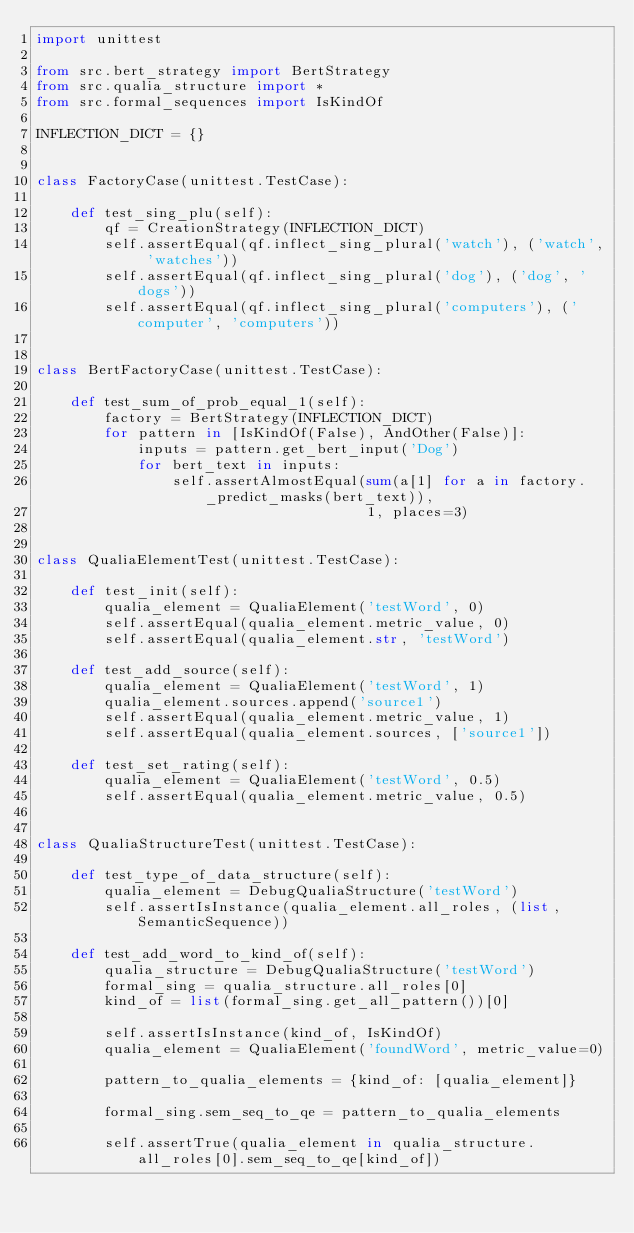Convert code to text. <code><loc_0><loc_0><loc_500><loc_500><_Python_>import unittest

from src.bert_strategy import BertStrategy
from src.qualia_structure import *
from src.formal_sequences import IsKindOf

INFLECTION_DICT = {}


class FactoryCase(unittest.TestCase):

    def test_sing_plu(self):
        qf = CreationStrategy(INFLECTION_DICT)
        self.assertEqual(qf.inflect_sing_plural('watch'), ('watch', 'watches'))
        self.assertEqual(qf.inflect_sing_plural('dog'), ('dog', 'dogs'))
        self.assertEqual(qf.inflect_sing_plural('computers'), ('computer', 'computers'))


class BertFactoryCase(unittest.TestCase):

    def test_sum_of_prob_equal_1(self):
        factory = BertStrategy(INFLECTION_DICT)
        for pattern in [IsKindOf(False), AndOther(False)]:
            inputs = pattern.get_bert_input('Dog')
            for bert_text in inputs:
                self.assertAlmostEqual(sum(a[1] for a in factory._predict_masks(bert_text)),
                                       1, places=3)


class QualiaElementTest(unittest.TestCase):

    def test_init(self):
        qualia_element = QualiaElement('testWord', 0)
        self.assertEqual(qualia_element.metric_value, 0)
        self.assertEqual(qualia_element.str, 'testWord')

    def test_add_source(self):
        qualia_element = QualiaElement('testWord', 1)
        qualia_element.sources.append('source1')
        self.assertEqual(qualia_element.metric_value, 1)
        self.assertEqual(qualia_element.sources, ['source1'])

    def test_set_rating(self):
        qualia_element = QualiaElement('testWord', 0.5)
        self.assertEqual(qualia_element.metric_value, 0.5)


class QualiaStructureTest(unittest.TestCase):

    def test_type_of_data_structure(self):
        qualia_element = DebugQualiaStructure('testWord')
        self.assertIsInstance(qualia_element.all_roles, (list, SemanticSequence))

    def test_add_word_to_kind_of(self):
        qualia_structure = DebugQualiaStructure('testWord')
        formal_sing = qualia_structure.all_roles[0]
        kind_of = list(formal_sing.get_all_pattern())[0]

        self.assertIsInstance(kind_of, IsKindOf)
        qualia_element = QualiaElement('foundWord', metric_value=0)

        pattern_to_qualia_elements = {kind_of: [qualia_element]}

        formal_sing.sem_seq_to_qe = pattern_to_qualia_elements

        self.assertTrue(qualia_element in qualia_structure.all_roles[0].sem_seq_to_qe[kind_of])
</code> 